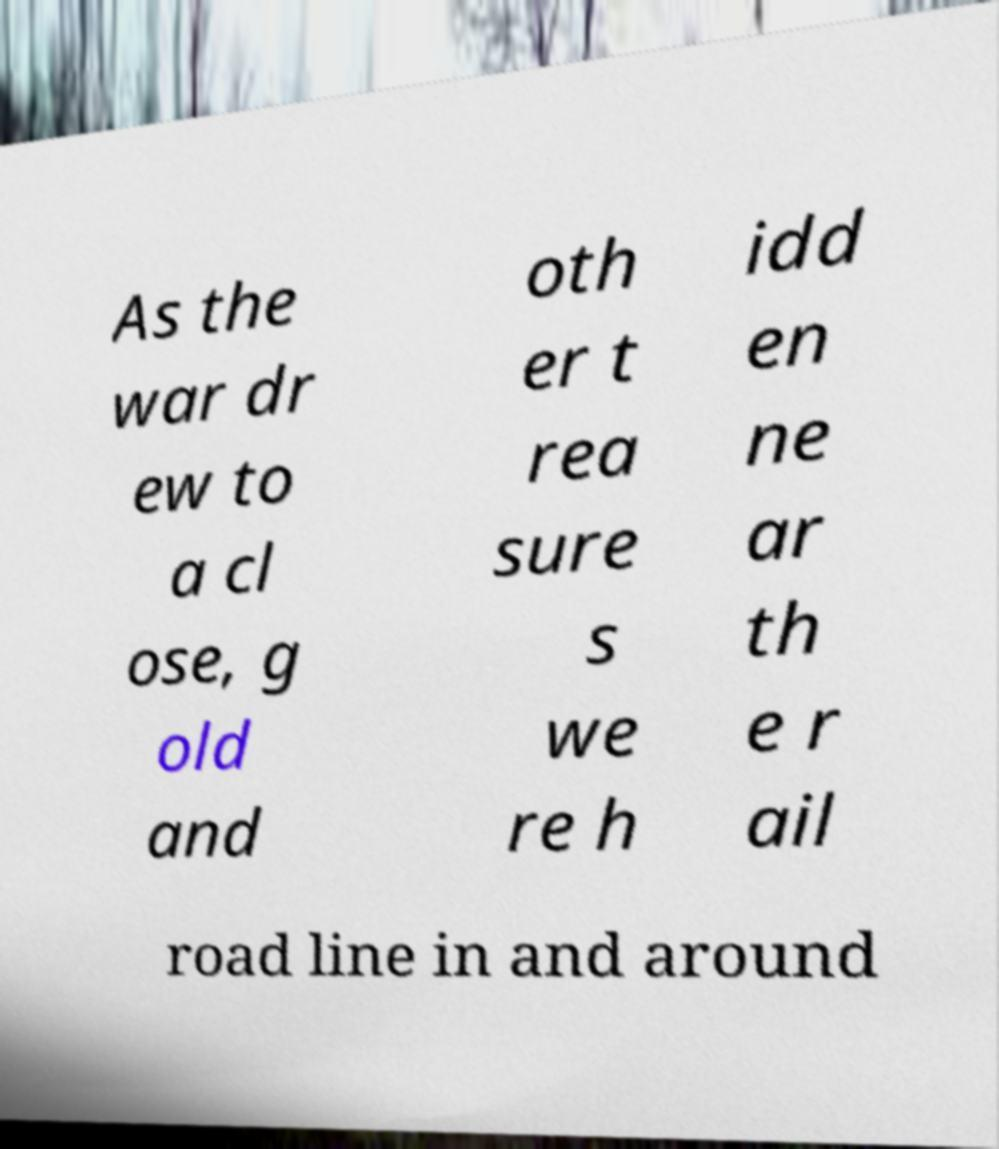Could you extract and type out the text from this image? As the war dr ew to a cl ose, g old and oth er t rea sure s we re h idd en ne ar th e r ail road line in and around 